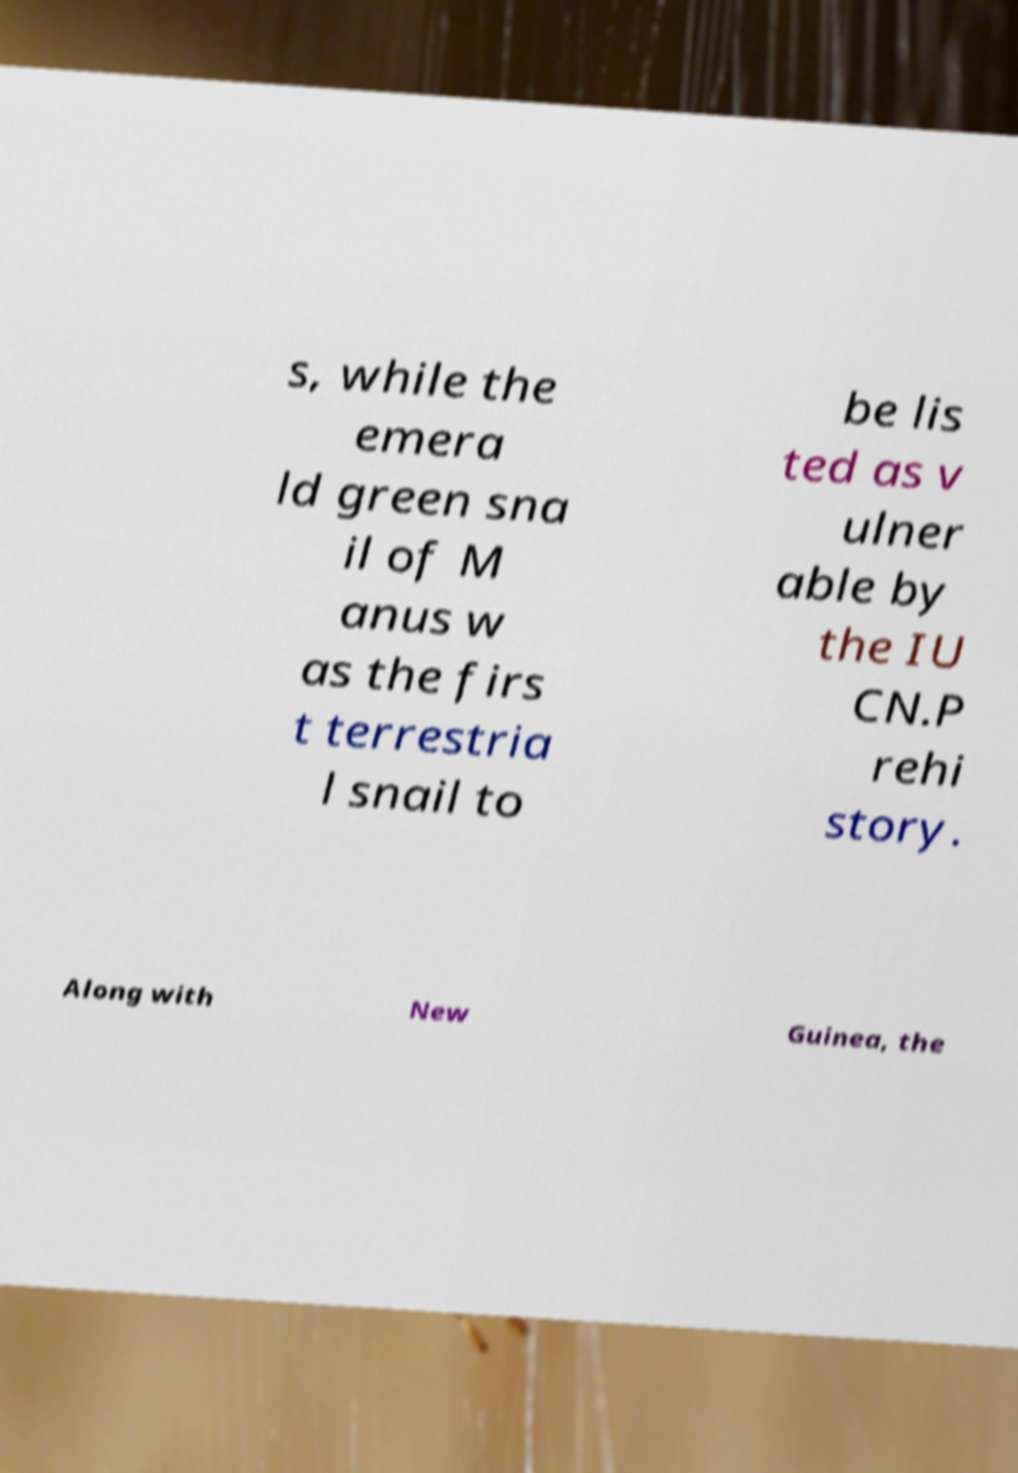Please read and relay the text visible in this image. What does it say? s, while the emera ld green sna il of M anus w as the firs t terrestria l snail to be lis ted as v ulner able by the IU CN.P rehi story. Along with New Guinea, the 